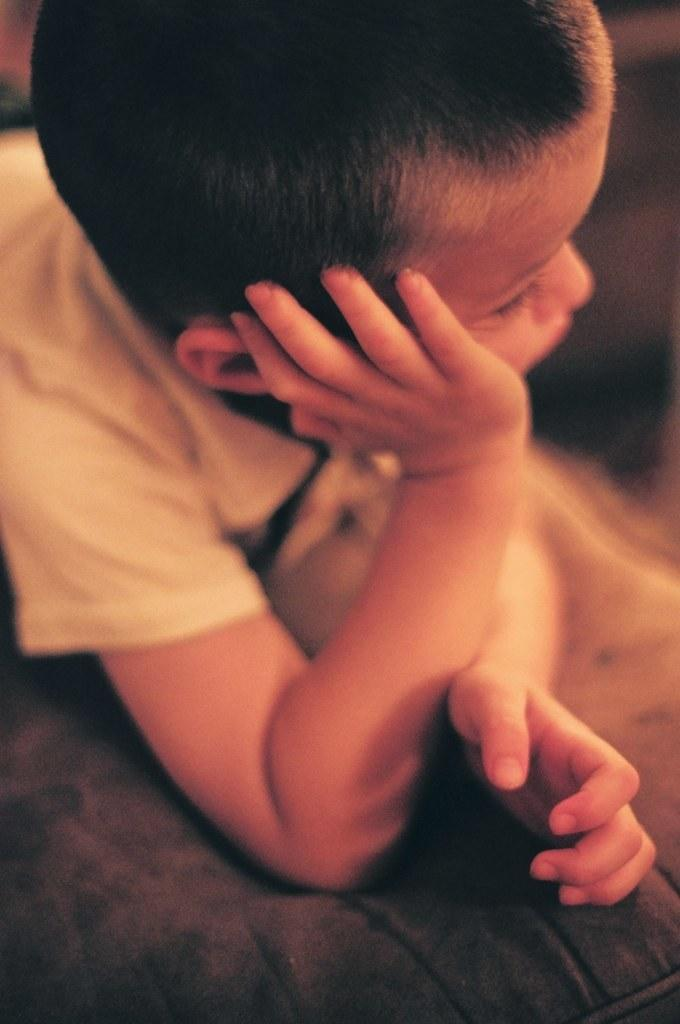What is the main subject of the image? There is a boy in the image. What type of key is the boy using to unlock the tent in the image? There is no key, tent, or any indication of unlocking in the image; it only features a boy. 